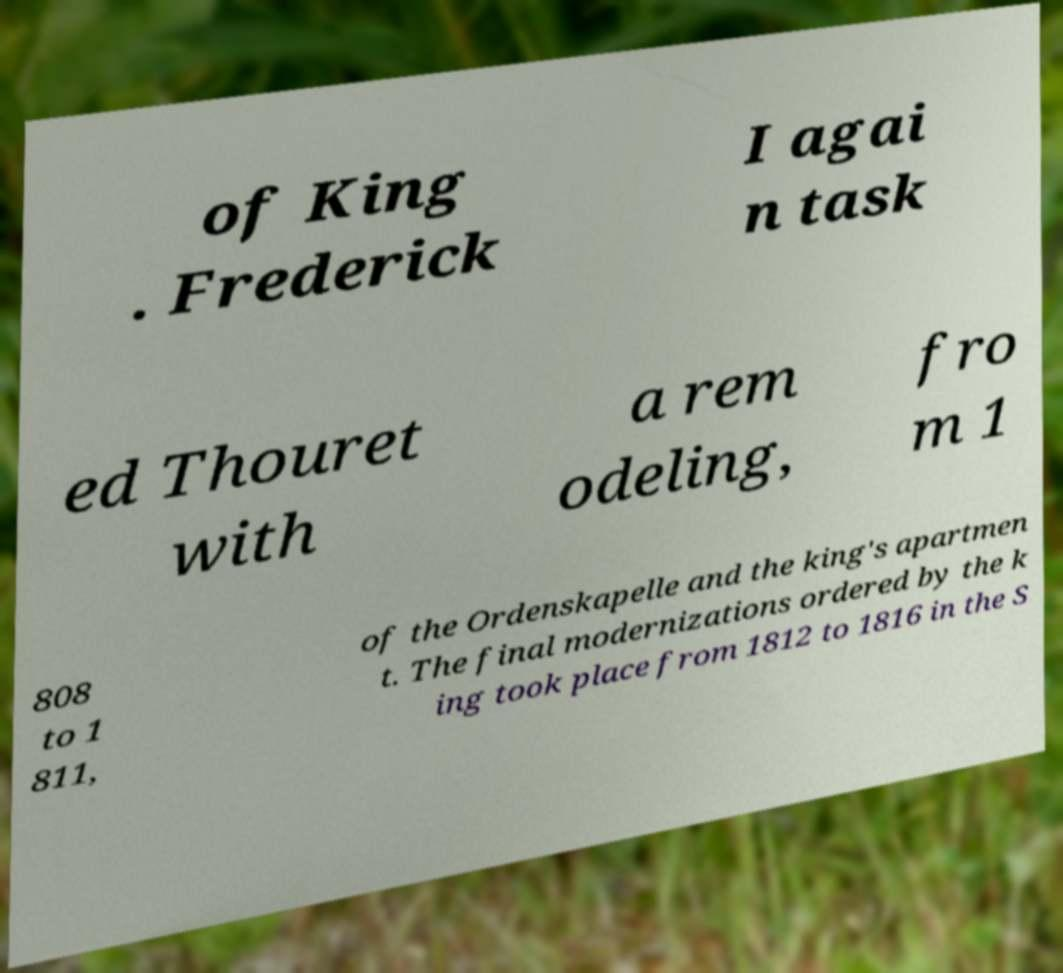For documentation purposes, I need the text within this image transcribed. Could you provide that? of King . Frederick I agai n task ed Thouret with a rem odeling, fro m 1 808 to 1 811, of the Ordenskapelle and the king's apartmen t. The final modernizations ordered by the k ing took place from 1812 to 1816 in the S 